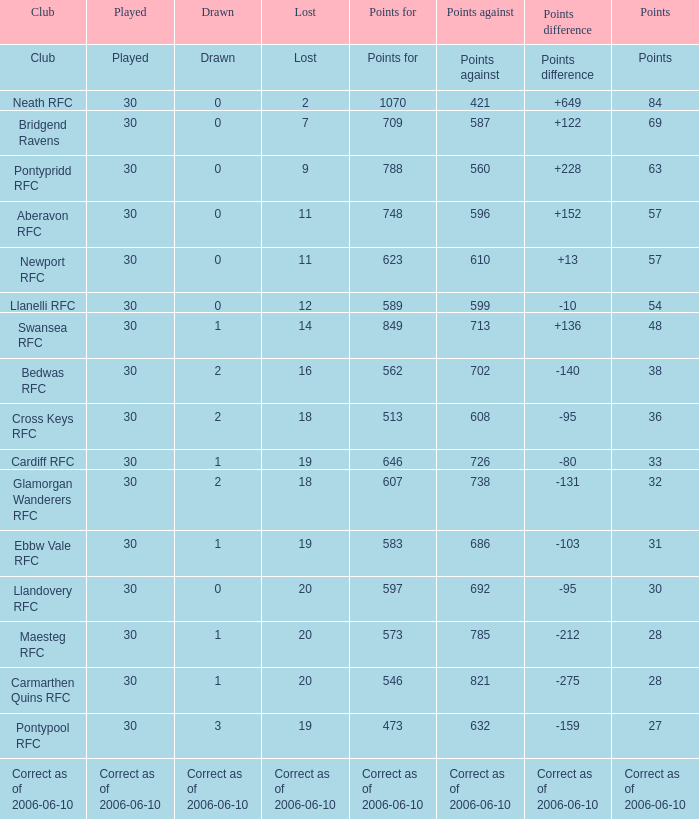What is Points Against, when Drawn is "2", and when Points Of is "32"? 738.0. Write the full table. {'header': ['Club', 'Played', 'Drawn', 'Lost', 'Points for', 'Points against', 'Points difference', 'Points'], 'rows': [['Club', 'Played', 'Drawn', 'Lost', 'Points for', 'Points against', 'Points difference', 'Points'], ['Neath RFC', '30', '0', '2', '1070', '421', '+649', '84'], ['Bridgend Ravens', '30', '0', '7', '709', '587', '+122', '69'], ['Pontypridd RFC', '30', '0', '9', '788', '560', '+228', '63'], ['Aberavon RFC', '30', '0', '11', '748', '596', '+152', '57'], ['Newport RFC', '30', '0', '11', '623', '610', '+13', '57'], ['Llanelli RFC', '30', '0', '12', '589', '599', '-10', '54'], ['Swansea RFC', '30', '1', '14', '849', '713', '+136', '48'], ['Bedwas RFC', '30', '2', '16', '562', '702', '-140', '38'], ['Cross Keys RFC', '30', '2', '18', '513', '608', '-95', '36'], ['Cardiff RFC', '30', '1', '19', '646', '726', '-80', '33'], ['Glamorgan Wanderers RFC', '30', '2', '18', '607', '738', '-131', '32'], ['Ebbw Vale RFC', '30', '1', '19', '583', '686', '-103', '31'], ['Llandovery RFC', '30', '0', '20', '597', '692', '-95', '30'], ['Maesteg RFC', '30', '1', '20', '573', '785', '-212', '28'], ['Carmarthen Quins RFC', '30', '1', '20', '546', '821', '-275', '28'], ['Pontypool RFC', '30', '3', '19', '473', '632', '-159', '27'], ['Correct as of 2006-06-10', 'Correct as of 2006-06-10', 'Correct as of 2006-06-10', 'Correct as of 2006-06-10', 'Correct as of 2006-06-10', 'Correct as of 2006-06-10', 'Correct as of 2006-06-10', 'Correct as of 2006-06-10']]} 